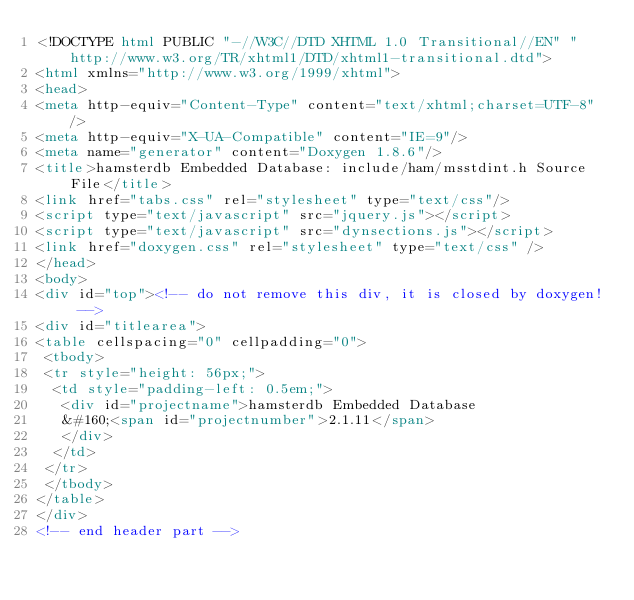Convert code to text. <code><loc_0><loc_0><loc_500><loc_500><_HTML_><!DOCTYPE html PUBLIC "-//W3C//DTD XHTML 1.0 Transitional//EN" "http://www.w3.org/TR/xhtml1/DTD/xhtml1-transitional.dtd">
<html xmlns="http://www.w3.org/1999/xhtml">
<head>
<meta http-equiv="Content-Type" content="text/xhtml;charset=UTF-8"/>
<meta http-equiv="X-UA-Compatible" content="IE=9"/>
<meta name="generator" content="Doxygen 1.8.6"/>
<title>hamsterdb Embedded Database: include/ham/msstdint.h Source File</title>
<link href="tabs.css" rel="stylesheet" type="text/css"/>
<script type="text/javascript" src="jquery.js"></script>
<script type="text/javascript" src="dynsections.js"></script>
<link href="doxygen.css" rel="stylesheet" type="text/css" />
</head>
<body>
<div id="top"><!-- do not remove this div, it is closed by doxygen! -->
<div id="titlearea">
<table cellspacing="0" cellpadding="0">
 <tbody>
 <tr style="height: 56px;">
  <td style="padding-left: 0.5em;">
   <div id="projectname">hamsterdb Embedded Database
   &#160;<span id="projectnumber">2.1.11</span>
   </div>
  </td>
 </tr>
 </tbody>
</table>
</div>
<!-- end header part --></code> 